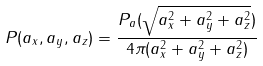<formula> <loc_0><loc_0><loc_500><loc_500>P ( a _ { x } , a _ { y } , a _ { z } ) = \frac { P _ { \| a \| } ( \sqrt { a _ { x } ^ { 2 } + a _ { y } ^ { 2 } + a _ { z } ^ { 2 } } ) } { 4 \pi ( a _ { x } ^ { 2 } + a _ { y } ^ { 2 } + a _ { z } ^ { 2 } ) }</formula> 